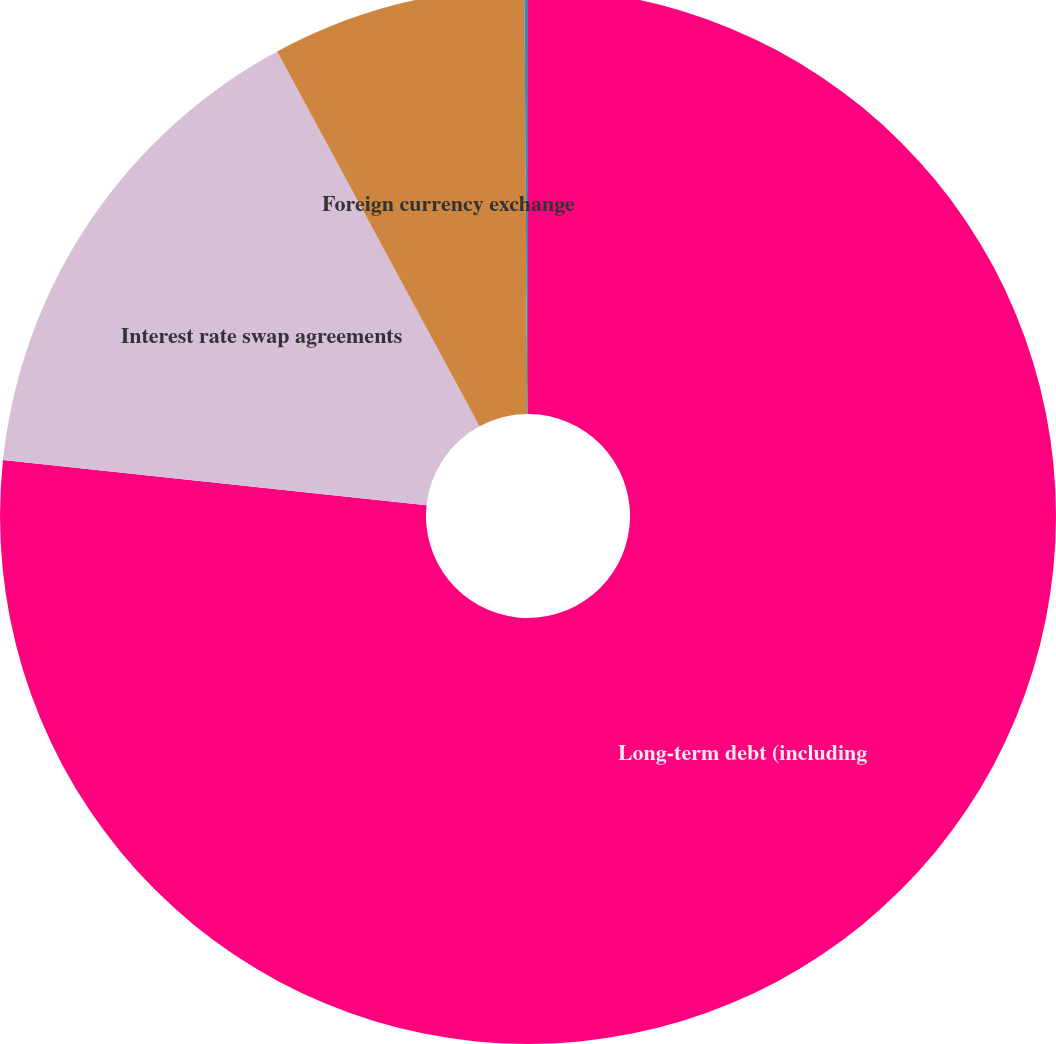Convert chart to OTSL. <chart><loc_0><loc_0><loc_500><loc_500><pie_chart><fcel>Long-term debt (including<fcel>Interest rate swap agreements<fcel>Foreign currency exchange<fcel>Forward commodity contracts(3)<nl><fcel>76.69%<fcel>15.43%<fcel>7.77%<fcel>0.11%<nl></chart> 